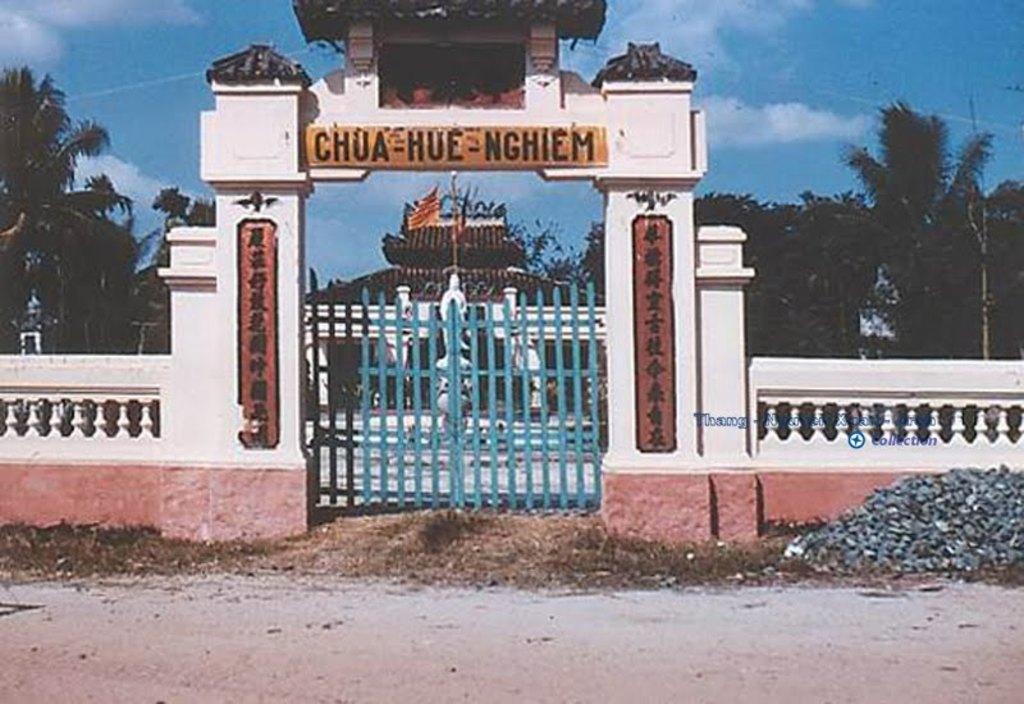Please provide a concise description of this image. In the picture I can see gates, fence and I can also see something written over here. In the background I can see a building, trees and the sky. 